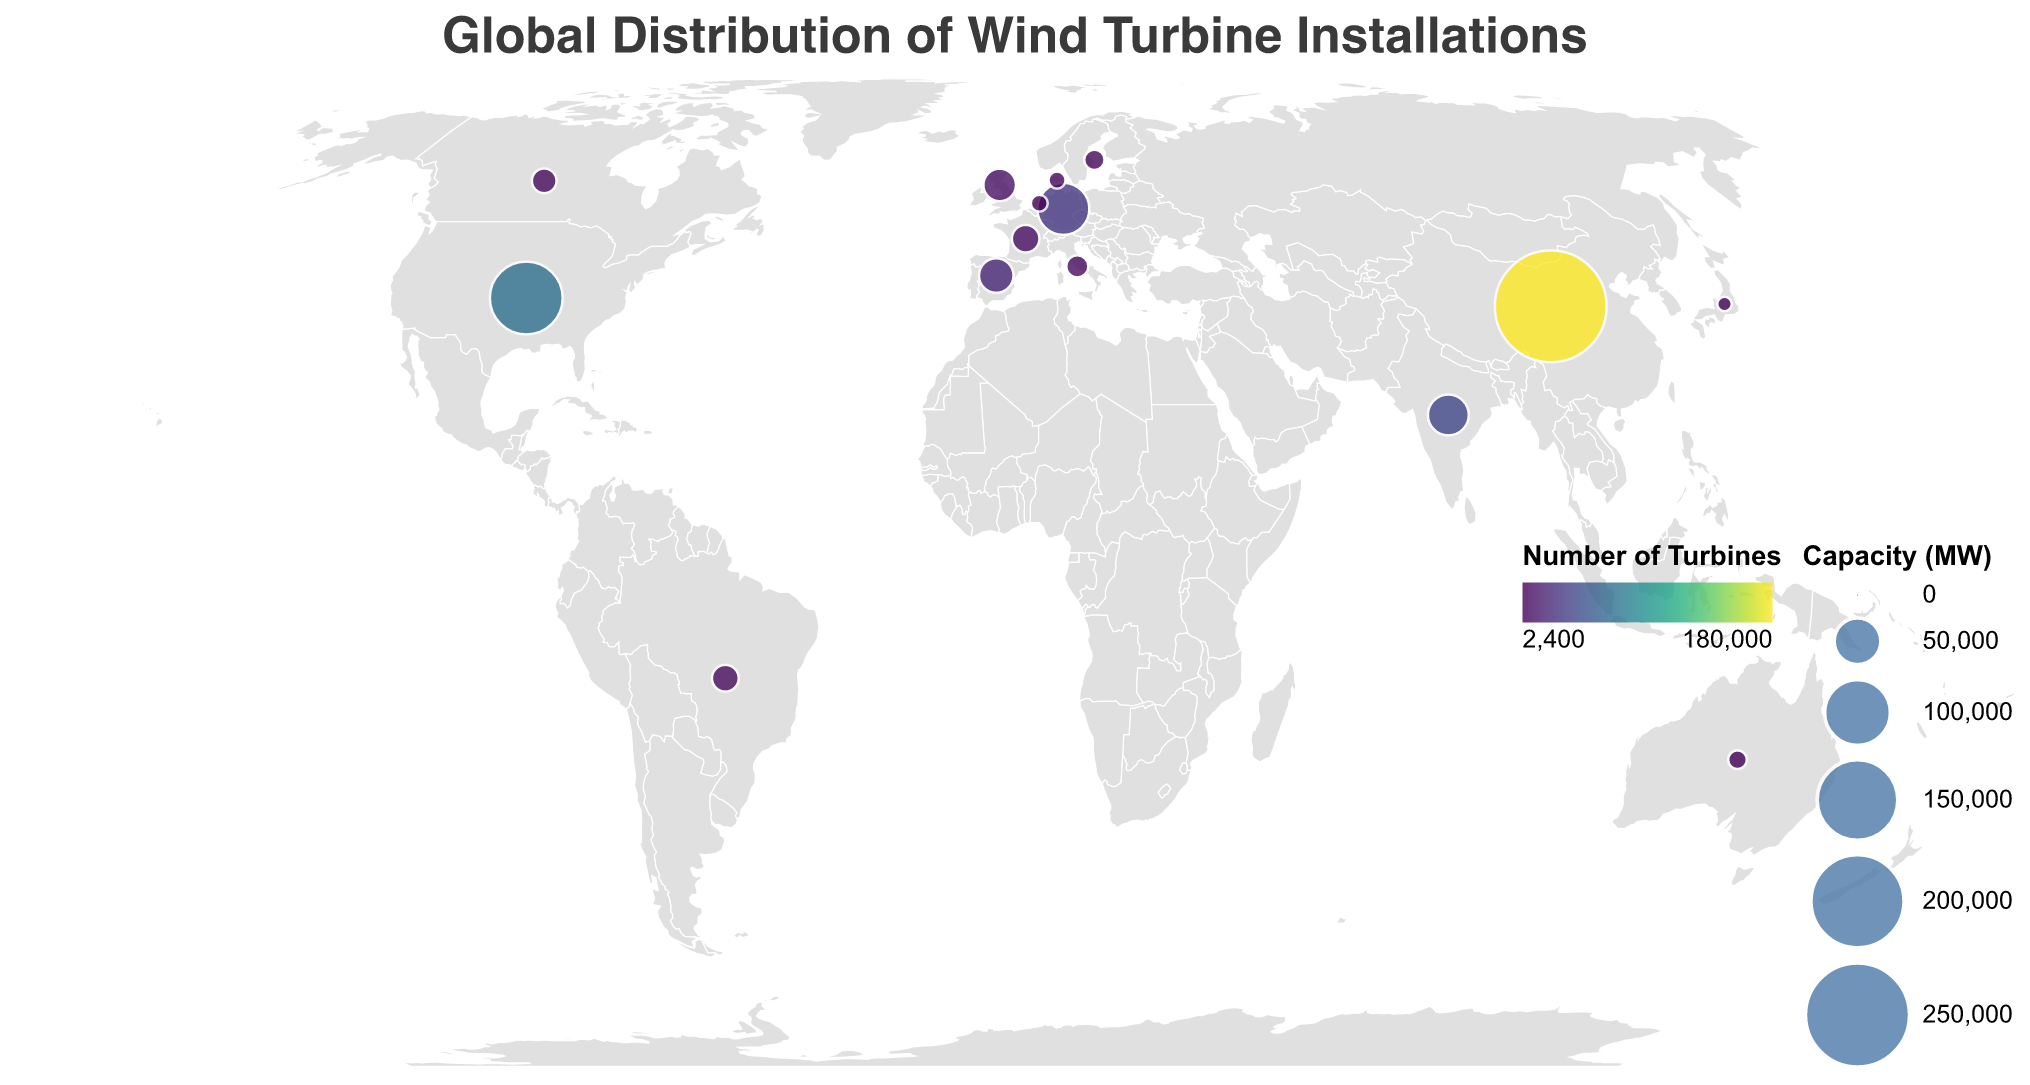What is the total capacity (in MW) of wind turbines installed in China? Look at the data point for China, where "Capacity_MW" is 288000.
Answer: 288000 Which country has the largest number of wind turbines installed? Compare the "Number_of_Turbines" across all countries. China has the largest value with 180000 turbines.
Answer: China What color scheme is used to represent the number of turbines? The color scheme used in the plot is "viridis".
Answer: viridis How is the capacity of wind turbines visually represented in the figure? The capacity is represented by the size of the circles. Larger circles indicate higher capacity.
Answer: Circle size What is the total number of wind turbines installed in Germany and India combined? Add the number of turbines in Germany (30000) to the number in India (40000). 30000 + 40000 = 70000.
Answer: 70000 Which country has a higher wind turbine capacity, the United States or Germany? Compare the "Capacity_MW" values for the United States (122000 MW) and Germany (62000 MW). The United States has a higher capacity.
Answer: United States Among the countries listed, which one has the lowest wind turbine capacity? Identify the country with the least "Capacity_MW". Japan has the lowest capacity with 4300 MW.
Answer: Japan What is the visual title of the geographic plot? The title is specified at the top of the plot. It reads "Global Distribution of Wind Turbine Installations".
Answer: Global Distribution of Wind Turbine Installations How many countries have more than 20000 MW of wind turbine capacity? Count the countries with a "Capacity_MW" greater than 20000. There are five such countries: China, United States, Germany, India, and Spain.
Answer: 5 